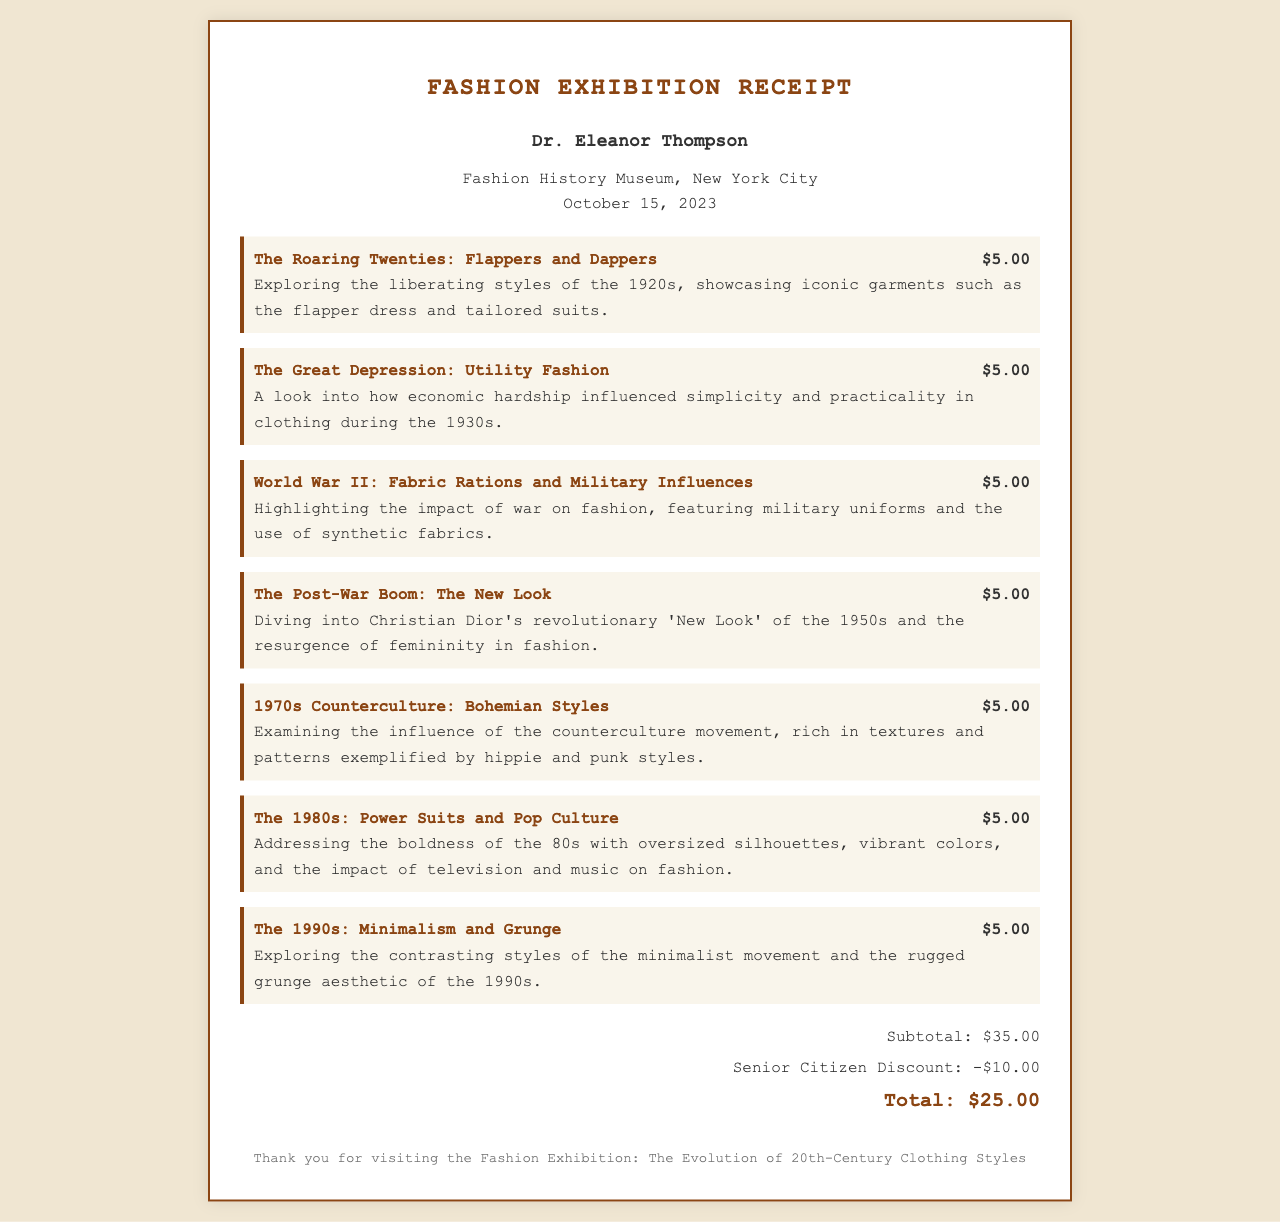What is the name of the visitor? The name of the visitor is highlighted prominently at the top of the receipt.
Answer: Dr. Eleanor Thompson What is the date of the visit? The date of the visit is mentioned in the header section of the receipt.
Answer: October 15, 2023 How many exhibits were visited? The number of exhibits can be counted from the list presented in the exhibits section.
Answer: 7 What was the entry fee for "The Roaring Twenties: Flappers and Dappers"? The entry fee for each exhibit is displayed next to the exhibit name in the document.
Answer: $5.00 What is the total amount paid after the discount? The total shows the final amount payable after applying the discount mentioned in the totals section.
Answer: $25.00 What was the amount of the Senior Citizen Discount? The discount amount is listed as a line item in the totals section of the receipt.
Answer: -$10.00 Which exhibit explores the influence of the counterculture movement? The exhibit names are shown with their respective descriptions, allowing identification of specific themes.
Answer: 1970s Counterculture: Bohemian Styles What is the subtotal before discounts? The subtotal is explicitly detailed in the receipt before any deductions for discounts.
Answer: $35.00 